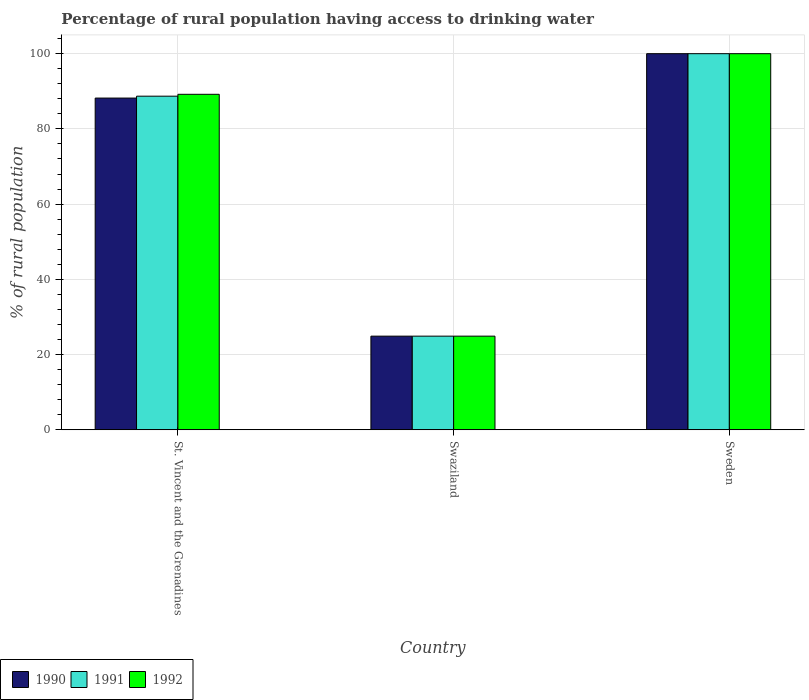How many different coloured bars are there?
Keep it short and to the point. 3. Are the number of bars per tick equal to the number of legend labels?
Your answer should be compact. Yes. How many bars are there on the 1st tick from the left?
Give a very brief answer. 3. How many bars are there on the 3rd tick from the right?
Keep it short and to the point. 3. What is the label of the 2nd group of bars from the left?
Make the answer very short. Swaziland. What is the percentage of rural population having access to drinking water in 1992 in Sweden?
Your response must be concise. 100. Across all countries, what is the maximum percentage of rural population having access to drinking water in 1990?
Provide a succinct answer. 100. Across all countries, what is the minimum percentage of rural population having access to drinking water in 1990?
Offer a terse response. 24.9. In which country was the percentage of rural population having access to drinking water in 1991 minimum?
Your answer should be compact. Swaziland. What is the total percentage of rural population having access to drinking water in 1991 in the graph?
Keep it short and to the point. 213.6. What is the difference between the percentage of rural population having access to drinking water in 1991 in Swaziland and that in Sweden?
Ensure brevity in your answer.  -75.1. What is the difference between the percentage of rural population having access to drinking water in 1991 in St. Vincent and the Grenadines and the percentage of rural population having access to drinking water in 1990 in Swaziland?
Ensure brevity in your answer.  63.8. What is the average percentage of rural population having access to drinking water in 1992 per country?
Offer a terse response. 71.37. What is the difference between the percentage of rural population having access to drinking water of/in 1992 and percentage of rural population having access to drinking water of/in 1991 in Sweden?
Provide a succinct answer. 0. In how many countries, is the percentage of rural population having access to drinking water in 1992 greater than 28 %?
Ensure brevity in your answer.  2. What is the ratio of the percentage of rural population having access to drinking water in 1992 in St. Vincent and the Grenadines to that in Swaziland?
Offer a very short reply. 3.58. Is the difference between the percentage of rural population having access to drinking water in 1992 in St. Vincent and the Grenadines and Swaziland greater than the difference between the percentage of rural population having access to drinking water in 1991 in St. Vincent and the Grenadines and Swaziland?
Ensure brevity in your answer.  Yes. What is the difference between the highest and the second highest percentage of rural population having access to drinking water in 1990?
Offer a terse response. 63.3. What is the difference between the highest and the lowest percentage of rural population having access to drinking water in 1991?
Your answer should be compact. 75.1. Is it the case that in every country, the sum of the percentage of rural population having access to drinking water in 1992 and percentage of rural population having access to drinking water in 1991 is greater than the percentage of rural population having access to drinking water in 1990?
Give a very brief answer. Yes. Are all the bars in the graph horizontal?
Offer a very short reply. No. How many countries are there in the graph?
Ensure brevity in your answer.  3. Are the values on the major ticks of Y-axis written in scientific E-notation?
Provide a short and direct response. No. Does the graph contain any zero values?
Your answer should be compact. No. Does the graph contain grids?
Give a very brief answer. Yes. Where does the legend appear in the graph?
Your answer should be very brief. Bottom left. How many legend labels are there?
Offer a terse response. 3. How are the legend labels stacked?
Your answer should be very brief. Horizontal. What is the title of the graph?
Ensure brevity in your answer.  Percentage of rural population having access to drinking water. Does "1984" appear as one of the legend labels in the graph?
Ensure brevity in your answer.  No. What is the label or title of the Y-axis?
Keep it short and to the point. % of rural population. What is the % of rural population in 1990 in St. Vincent and the Grenadines?
Your answer should be very brief. 88.2. What is the % of rural population in 1991 in St. Vincent and the Grenadines?
Keep it short and to the point. 88.7. What is the % of rural population of 1992 in St. Vincent and the Grenadines?
Offer a very short reply. 89.2. What is the % of rural population of 1990 in Swaziland?
Keep it short and to the point. 24.9. What is the % of rural population of 1991 in Swaziland?
Keep it short and to the point. 24.9. What is the % of rural population in 1992 in Swaziland?
Offer a terse response. 24.9. What is the % of rural population in 1990 in Sweden?
Your response must be concise. 100. Across all countries, what is the maximum % of rural population in 1992?
Your answer should be very brief. 100. Across all countries, what is the minimum % of rural population of 1990?
Your answer should be very brief. 24.9. Across all countries, what is the minimum % of rural population in 1991?
Offer a terse response. 24.9. Across all countries, what is the minimum % of rural population of 1992?
Provide a succinct answer. 24.9. What is the total % of rural population in 1990 in the graph?
Make the answer very short. 213.1. What is the total % of rural population in 1991 in the graph?
Make the answer very short. 213.6. What is the total % of rural population of 1992 in the graph?
Give a very brief answer. 214.1. What is the difference between the % of rural population of 1990 in St. Vincent and the Grenadines and that in Swaziland?
Provide a succinct answer. 63.3. What is the difference between the % of rural population in 1991 in St. Vincent and the Grenadines and that in Swaziland?
Ensure brevity in your answer.  63.8. What is the difference between the % of rural population of 1992 in St. Vincent and the Grenadines and that in Swaziland?
Ensure brevity in your answer.  64.3. What is the difference between the % of rural population of 1990 in St. Vincent and the Grenadines and that in Sweden?
Your answer should be very brief. -11.8. What is the difference between the % of rural population in 1991 in St. Vincent and the Grenadines and that in Sweden?
Your response must be concise. -11.3. What is the difference between the % of rural population of 1990 in Swaziland and that in Sweden?
Offer a very short reply. -75.1. What is the difference between the % of rural population of 1991 in Swaziland and that in Sweden?
Provide a succinct answer. -75.1. What is the difference between the % of rural population of 1992 in Swaziland and that in Sweden?
Ensure brevity in your answer.  -75.1. What is the difference between the % of rural population in 1990 in St. Vincent and the Grenadines and the % of rural population in 1991 in Swaziland?
Your response must be concise. 63.3. What is the difference between the % of rural population of 1990 in St. Vincent and the Grenadines and the % of rural population of 1992 in Swaziland?
Offer a terse response. 63.3. What is the difference between the % of rural population in 1991 in St. Vincent and the Grenadines and the % of rural population in 1992 in Swaziland?
Your answer should be compact. 63.8. What is the difference between the % of rural population of 1991 in St. Vincent and the Grenadines and the % of rural population of 1992 in Sweden?
Give a very brief answer. -11.3. What is the difference between the % of rural population in 1990 in Swaziland and the % of rural population in 1991 in Sweden?
Provide a succinct answer. -75.1. What is the difference between the % of rural population of 1990 in Swaziland and the % of rural population of 1992 in Sweden?
Offer a terse response. -75.1. What is the difference between the % of rural population in 1991 in Swaziland and the % of rural population in 1992 in Sweden?
Provide a succinct answer. -75.1. What is the average % of rural population in 1990 per country?
Make the answer very short. 71.03. What is the average % of rural population of 1991 per country?
Make the answer very short. 71.2. What is the average % of rural population of 1992 per country?
Make the answer very short. 71.37. What is the difference between the % of rural population of 1990 and % of rural population of 1991 in St. Vincent and the Grenadines?
Offer a very short reply. -0.5. What is the difference between the % of rural population of 1991 and % of rural population of 1992 in St. Vincent and the Grenadines?
Make the answer very short. -0.5. What is the difference between the % of rural population of 1990 and % of rural population of 1992 in Swaziland?
Your response must be concise. 0. What is the difference between the % of rural population in 1991 and % of rural population in 1992 in Swaziland?
Keep it short and to the point. 0. What is the difference between the % of rural population of 1991 and % of rural population of 1992 in Sweden?
Keep it short and to the point. 0. What is the ratio of the % of rural population of 1990 in St. Vincent and the Grenadines to that in Swaziland?
Ensure brevity in your answer.  3.54. What is the ratio of the % of rural population in 1991 in St. Vincent and the Grenadines to that in Swaziland?
Offer a very short reply. 3.56. What is the ratio of the % of rural population in 1992 in St. Vincent and the Grenadines to that in Swaziland?
Provide a succinct answer. 3.58. What is the ratio of the % of rural population in 1990 in St. Vincent and the Grenadines to that in Sweden?
Offer a terse response. 0.88. What is the ratio of the % of rural population of 1991 in St. Vincent and the Grenadines to that in Sweden?
Keep it short and to the point. 0.89. What is the ratio of the % of rural population in 1992 in St. Vincent and the Grenadines to that in Sweden?
Make the answer very short. 0.89. What is the ratio of the % of rural population of 1990 in Swaziland to that in Sweden?
Make the answer very short. 0.25. What is the ratio of the % of rural population in 1991 in Swaziland to that in Sweden?
Your response must be concise. 0.25. What is the ratio of the % of rural population of 1992 in Swaziland to that in Sweden?
Make the answer very short. 0.25. What is the difference between the highest and the second highest % of rural population in 1991?
Provide a succinct answer. 11.3. What is the difference between the highest and the second highest % of rural population in 1992?
Provide a succinct answer. 10.8. What is the difference between the highest and the lowest % of rural population of 1990?
Provide a succinct answer. 75.1. What is the difference between the highest and the lowest % of rural population in 1991?
Offer a very short reply. 75.1. What is the difference between the highest and the lowest % of rural population of 1992?
Your response must be concise. 75.1. 